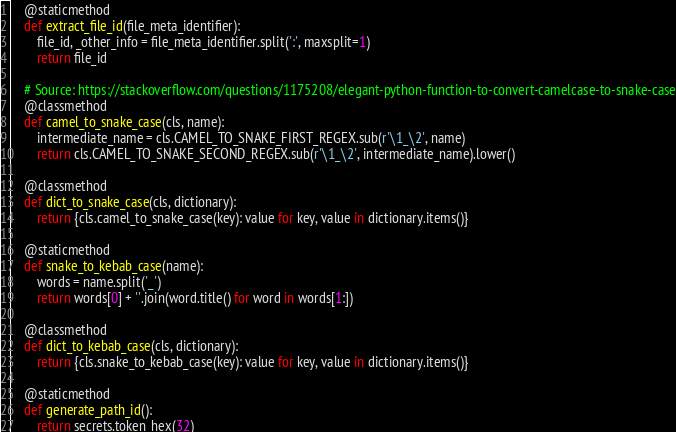<code> <loc_0><loc_0><loc_500><loc_500><_Python_>
    @staticmethod
    def extract_file_id(file_meta_identifier):
        file_id, _other_info = file_meta_identifier.split(':', maxsplit=1)
        return file_id

    # Source: https://stackoverflow.com/questions/1175208/elegant-python-function-to-convert-camelcase-to-snake-case
    @classmethod
    def camel_to_snake_case(cls, name):
        intermediate_name = cls.CAMEL_TO_SNAKE_FIRST_REGEX.sub(r'\1_\2', name)
        return cls.CAMEL_TO_SNAKE_SECOND_REGEX.sub(r'\1_\2', intermediate_name).lower()

    @classmethod
    def dict_to_snake_case(cls, dictionary):
        return {cls.camel_to_snake_case(key): value for key, value in dictionary.items()}

    @staticmethod
    def snake_to_kebab_case(name):
        words = name.split('_')
        return words[0] + ''.join(word.title() for word in words[1:])

    @classmethod
    def dict_to_kebab_case(cls, dictionary):
        return {cls.snake_to_kebab_case(key): value for key, value in dictionary.items()}

    @staticmethod
    def generate_path_id():
        return secrets.token_hex(32)
</code> 